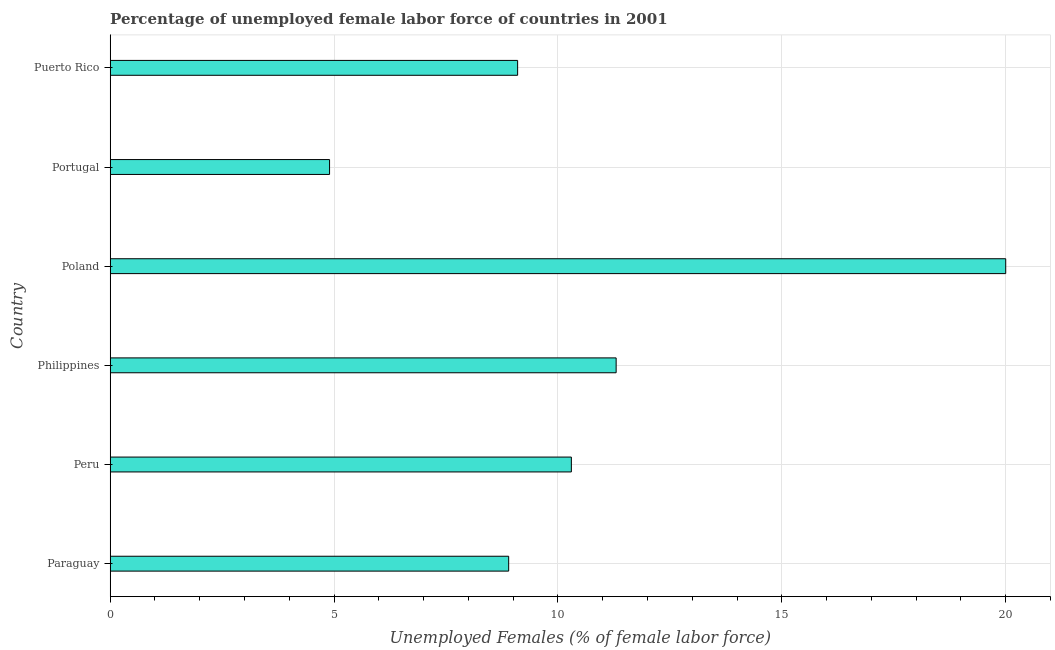What is the title of the graph?
Your answer should be very brief. Percentage of unemployed female labor force of countries in 2001. What is the label or title of the X-axis?
Keep it short and to the point. Unemployed Females (% of female labor force). What is the total unemployed female labour force in Poland?
Your answer should be compact. 20. Across all countries, what is the minimum total unemployed female labour force?
Provide a short and direct response. 4.9. In which country was the total unemployed female labour force maximum?
Ensure brevity in your answer.  Poland. In which country was the total unemployed female labour force minimum?
Ensure brevity in your answer.  Portugal. What is the sum of the total unemployed female labour force?
Ensure brevity in your answer.  64.5. What is the average total unemployed female labour force per country?
Ensure brevity in your answer.  10.75. What is the median total unemployed female labour force?
Ensure brevity in your answer.  9.7. In how many countries, is the total unemployed female labour force greater than 17 %?
Your answer should be very brief. 1. What is the ratio of the total unemployed female labour force in Paraguay to that in Philippines?
Your answer should be compact. 0.79. What is the difference between the highest and the lowest total unemployed female labour force?
Your response must be concise. 15.1. How many countries are there in the graph?
Your answer should be very brief. 6. Are the values on the major ticks of X-axis written in scientific E-notation?
Offer a terse response. No. What is the Unemployed Females (% of female labor force) of Paraguay?
Your response must be concise. 8.9. What is the Unemployed Females (% of female labor force) in Peru?
Your response must be concise. 10.3. What is the Unemployed Females (% of female labor force) of Philippines?
Offer a very short reply. 11.3. What is the Unemployed Females (% of female labor force) of Portugal?
Keep it short and to the point. 4.9. What is the Unemployed Females (% of female labor force) of Puerto Rico?
Keep it short and to the point. 9.1. What is the difference between the Unemployed Females (% of female labor force) in Paraguay and Portugal?
Provide a succinct answer. 4. What is the difference between the Unemployed Females (% of female labor force) in Peru and Philippines?
Provide a short and direct response. -1. What is the difference between the Unemployed Females (% of female labor force) in Peru and Poland?
Keep it short and to the point. -9.7. What is the difference between the Unemployed Females (% of female labor force) in Peru and Puerto Rico?
Provide a short and direct response. 1.2. What is the difference between the Unemployed Females (% of female labor force) in Poland and Portugal?
Make the answer very short. 15.1. What is the ratio of the Unemployed Females (% of female labor force) in Paraguay to that in Peru?
Make the answer very short. 0.86. What is the ratio of the Unemployed Females (% of female labor force) in Paraguay to that in Philippines?
Keep it short and to the point. 0.79. What is the ratio of the Unemployed Females (% of female labor force) in Paraguay to that in Poland?
Your answer should be very brief. 0.45. What is the ratio of the Unemployed Females (% of female labor force) in Paraguay to that in Portugal?
Make the answer very short. 1.82. What is the ratio of the Unemployed Females (% of female labor force) in Paraguay to that in Puerto Rico?
Your response must be concise. 0.98. What is the ratio of the Unemployed Females (% of female labor force) in Peru to that in Philippines?
Offer a very short reply. 0.91. What is the ratio of the Unemployed Females (% of female labor force) in Peru to that in Poland?
Give a very brief answer. 0.52. What is the ratio of the Unemployed Females (% of female labor force) in Peru to that in Portugal?
Your response must be concise. 2.1. What is the ratio of the Unemployed Females (% of female labor force) in Peru to that in Puerto Rico?
Ensure brevity in your answer.  1.13. What is the ratio of the Unemployed Females (% of female labor force) in Philippines to that in Poland?
Give a very brief answer. 0.56. What is the ratio of the Unemployed Females (% of female labor force) in Philippines to that in Portugal?
Your answer should be very brief. 2.31. What is the ratio of the Unemployed Females (% of female labor force) in Philippines to that in Puerto Rico?
Make the answer very short. 1.24. What is the ratio of the Unemployed Females (% of female labor force) in Poland to that in Portugal?
Your answer should be very brief. 4.08. What is the ratio of the Unemployed Females (% of female labor force) in Poland to that in Puerto Rico?
Keep it short and to the point. 2.2. What is the ratio of the Unemployed Females (% of female labor force) in Portugal to that in Puerto Rico?
Your answer should be very brief. 0.54. 